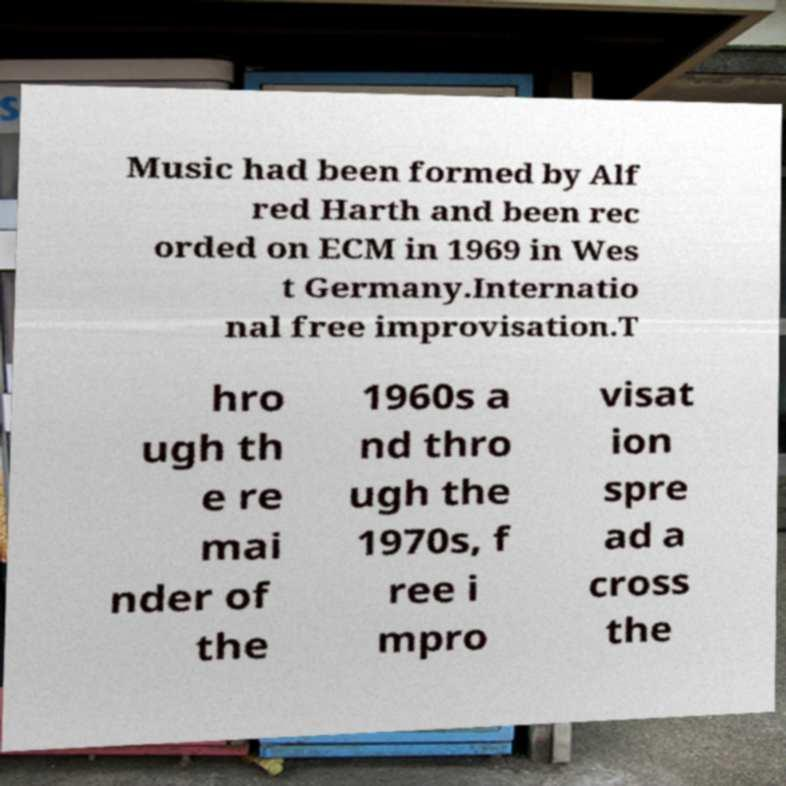Can you read and provide the text displayed in the image?This photo seems to have some interesting text. Can you extract and type it out for me? Music had been formed by Alf red Harth and been rec orded on ECM in 1969 in Wes t Germany.Internatio nal free improvisation.T hro ugh th e re mai nder of the 1960s a nd thro ugh the 1970s, f ree i mpro visat ion spre ad a cross the 